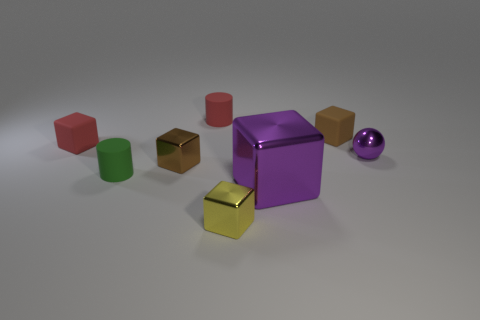Subtract all blue cylinders. Subtract all brown cubes. How many cylinders are left? 2 Subtract all red cylinders. How many blue balls are left? 0 Add 6 tiny purples. How many reds exist? 0 Subtract all large red metallic cubes. Subtract all shiny balls. How many objects are left? 7 Add 3 green matte cylinders. How many green matte cylinders are left? 4 Add 2 shiny blocks. How many shiny blocks exist? 5 Add 1 purple metallic spheres. How many objects exist? 9 Subtract all brown blocks. How many blocks are left? 3 Subtract all tiny yellow metallic blocks. How many blocks are left? 4 Subtract 0 brown cylinders. How many objects are left? 8 